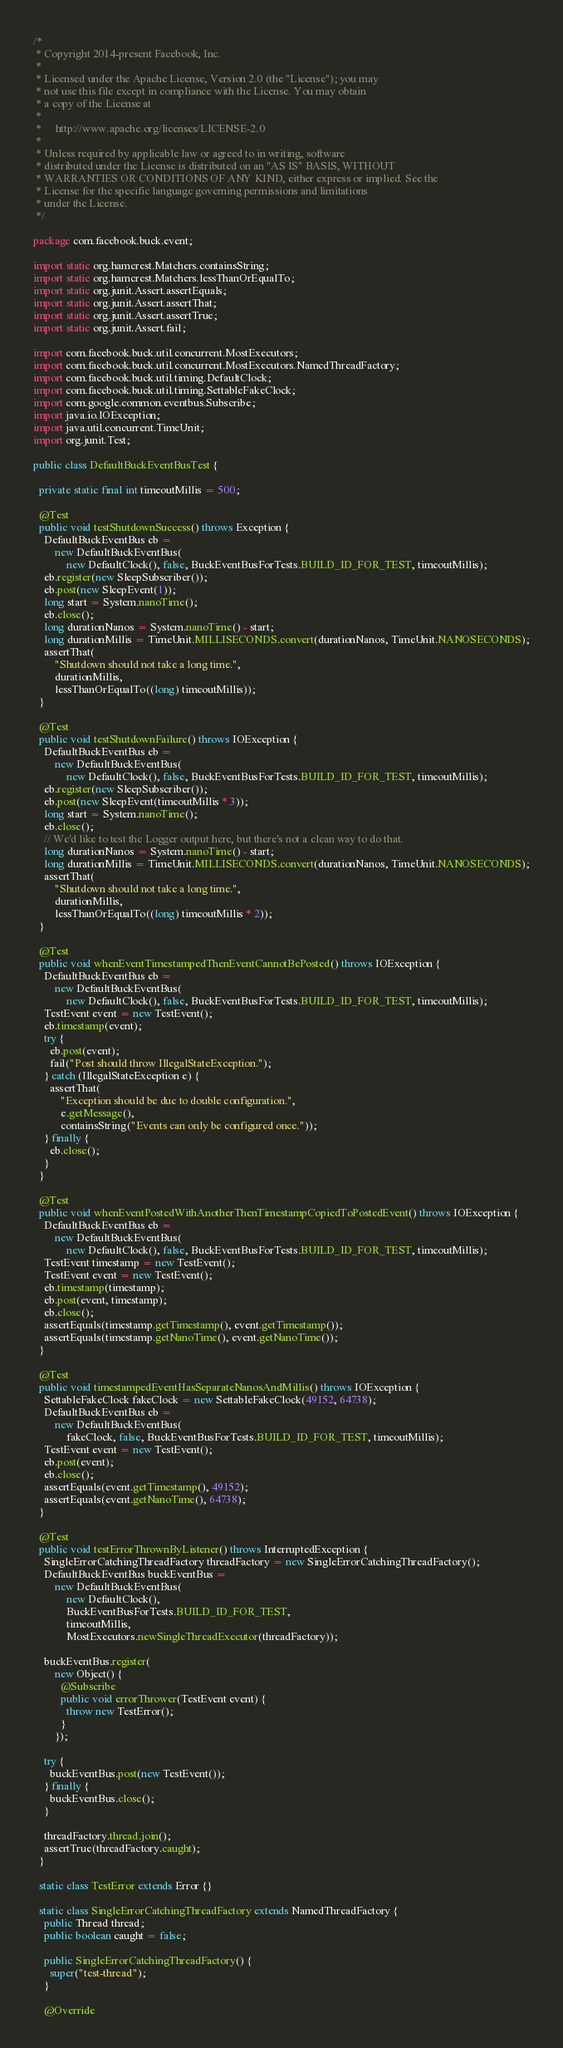<code> <loc_0><loc_0><loc_500><loc_500><_Java_>/*
 * Copyright 2014-present Facebook, Inc.
 *
 * Licensed under the Apache License, Version 2.0 (the "License"); you may
 * not use this file except in compliance with the License. You may obtain
 * a copy of the License at
 *
 *     http://www.apache.org/licenses/LICENSE-2.0
 *
 * Unless required by applicable law or agreed to in writing, software
 * distributed under the License is distributed on an "AS IS" BASIS, WITHOUT
 * WARRANTIES OR CONDITIONS OF ANY KIND, either express or implied. See the
 * License for the specific language governing permissions and limitations
 * under the License.
 */

package com.facebook.buck.event;

import static org.hamcrest.Matchers.containsString;
import static org.hamcrest.Matchers.lessThanOrEqualTo;
import static org.junit.Assert.assertEquals;
import static org.junit.Assert.assertThat;
import static org.junit.Assert.assertTrue;
import static org.junit.Assert.fail;

import com.facebook.buck.util.concurrent.MostExecutors;
import com.facebook.buck.util.concurrent.MostExecutors.NamedThreadFactory;
import com.facebook.buck.util.timing.DefaultClock;
import com.facebook.buck.util.timing.SettableFakeClock;
import com.google.common.eventbus.Subscribe;
import java.io.IOException;
import java.util.concurrent.TimeUnit;
import org.junit.Test;

public class DefaultBuckEventBusTest {

  private static final int timeoutMillis = 500;

  @Test
  public void testShutdownSuccess() throws Exception {
    DefaultBuckEventBus eb =
        new DefaultBuckEventBus(
            new DefaultClock(), false, BuckEventBusForTests.BUILD_ID_FOR_TEST, timeoutMillis);
    eb.register(new SleepSubscriber());
    eb.post(new SleepEvent(1));
    long start = System.nanoTime();
    eb.close();
    long durationNanos = System.nanoTime() - start;
    long durationMillis = TimeUnit.MILLISECONDS.convert(durationNanos, TimeUnit.NANOSECONDS);
    assertThat(
        "Shutdown should not take a long time.",
        durationMillis,
        lessThanOrEqualTo((long) timeoutMillis));
  }

  @Test
  public void testShutdownFailure() throws IOException {
    DefaultBuckEventBus eb =
        new DefaultBuckEventBus(
            new DefaultClock(), false, BuckEventBusForTests.BUILD_ID_FOR_TEST, timeoutMillis);
    eb.register(new SleepSubscriber());
    eb.post(new SleepEvent(timeoutMillis * 3));
    long start = System.nanoTime();
    eb.close();
    // We'd like to test the Logger output here, but there's not a clean way to do that.
    long durationNanos = System.nanoTime() - start;
    long durationMillis = TimeUnit.MILLISECONDS.convert(durationNanos, TimeUnit.NANOSECONDS);
    assertThat(
        "Shutdown should not take a long time.",
        durationMillis,
        lessThanOrEqualTo((long) timeoutMillis * 2));
  }

  @Test
  public void whenEventTimestampedThenEventCannotBePosted() throws IOException {
    DefaultBuckEventBus eb =
        new DefaultBuckEventBus(
            new DefaultClock(), false, BuckEventBusForTests.BUILD_ID_FOR_TEST, timeoutMillis);
    TestEvent event = new TestEvent();
    eb.timestamp(event);
    try {
      eb.post(event);
      fail("Post should throw IllegalStateException.");
    } catch (IllegalStateException e) {
      assertThat(
          "Exception should be due to double configuration.",
          e.getMessage(),
          containsString("Events can only be configured once."));
    } finally {
      eb.close();
    }
  }

  @Test
  public void whenEventPostedWithAnotherThenTimestampCopiedToPostedEvent() throws IOException {
    DefaultBuckEventBus eb =
        new DefaultBuckEventBus(
            new DefaultClock(), false, BuckEventBusForTests.BUILD_ID_FOR_TEST, timeoutMillis);
    TestEvent timestamp = new TestEvent();
    TestEvent event = new TestEvent();
    eb.timestamp(timestamp);
    eb.post(event, timestamp);
    eb.close();
    assertEquals(timestamp.getTimestamp(), event.getTimestamp());
    assertEquals(timestamp.getNanoTime(), event.getNanoTime());
  }

  @Test
  public void timestampedEventHasSeparateNanosAndMillis() throws IOException {
    SettableFakeClock fakeClock = new SettableFakeClock(49152, 64738);
    DefaultBuckEventBus eb =
        new DefaultBuckEventBus(
            fakeClock, false, BuckEventBusForTests.BUILD_ID_FOR_TEST, timeoutMillis);
    TestEvent event = new TestEvent();
    eb.post(event);
    eb.close();
    assertEquals(event.getTimestamp(), 49152);
    assertEquals(event.getNanoTime(), 64738);
  }

  @Test
  public void testErrorThrownByListener() throws InterruptedException {
    SingleErrorCatchingThreadFactory threadFactory = new SingleErrorCatchingThreadFactory();
    DefaultBuckEventBus buckEventBus =
        new DefaultBuckEventBus(
            new DefaultClock(),
            BuckEventBusForTests.BUILD_ID_FOR_TEST,
            timeoutMillis,
            MostExecutors.newSingleThreadExecutor(threadFactory));

    buckEventBus.register(
        new Object() {
          @Subscribe
          public void errorThrower(TestEvent event) {
            throw new TestError();
          }
        });

    try {
      buckEventBus.post(new TestEvent());
    } finally {
      buckEventBus.close();
    }

    threadFactory.thread.join();
    assertTrue(threadFactory.caught);
  }

  static class TestError extends Error {}

  static class SingleErrorCatchingThreadFactory extends NamedThreadFactory {
    public Thread thread;
    public boolean caught = false;

    public SingleErrorCatchingThreadFactory() {
      super("test-thread");
    }

    @Override</code> 